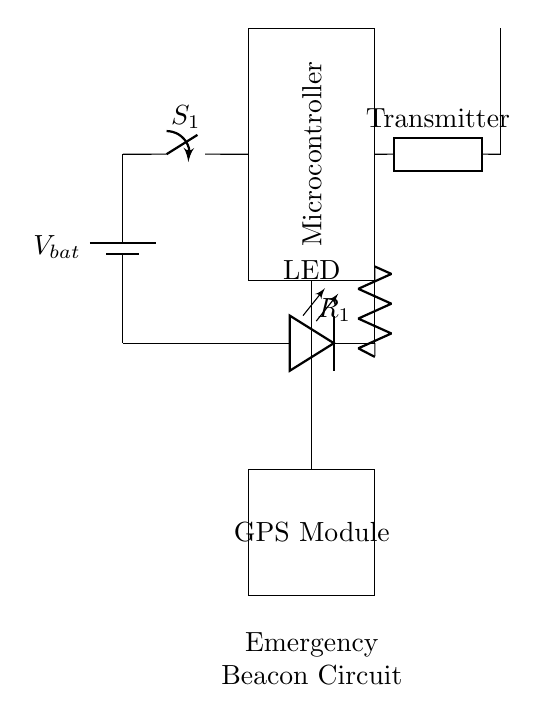What is the primary function of the microcontroller in this circuit? The microcontroller serves as the brain of the circuit, managing inputs from the GPS module and controlling the operations of the transmitter and LED based on those inputs.
Answer: Brain What does the LED indicate in this circuit? The LED likely indicates the status of the emergency beacon being active, turning on when the circuit is powered or when a specific condition is met.
Answer: Status What type of component is connected to the antenna? The transmitter is connected to the antenna, allowing the circuit to send out signals for communication and alerts.
Answer: Transmitter What is the role of the switch in the circuit design? The switch allows for control over the entire circuit by enabling or disabling the connection to the power source, which can activate or deactivate the beacon's function.
Answer: Control How does the GPS module interact with the microcontroller? The GPS module provides location data to the microcontroller, which processes this information to determine whether to activate the emergency transmission.
Answer: Provides location data 